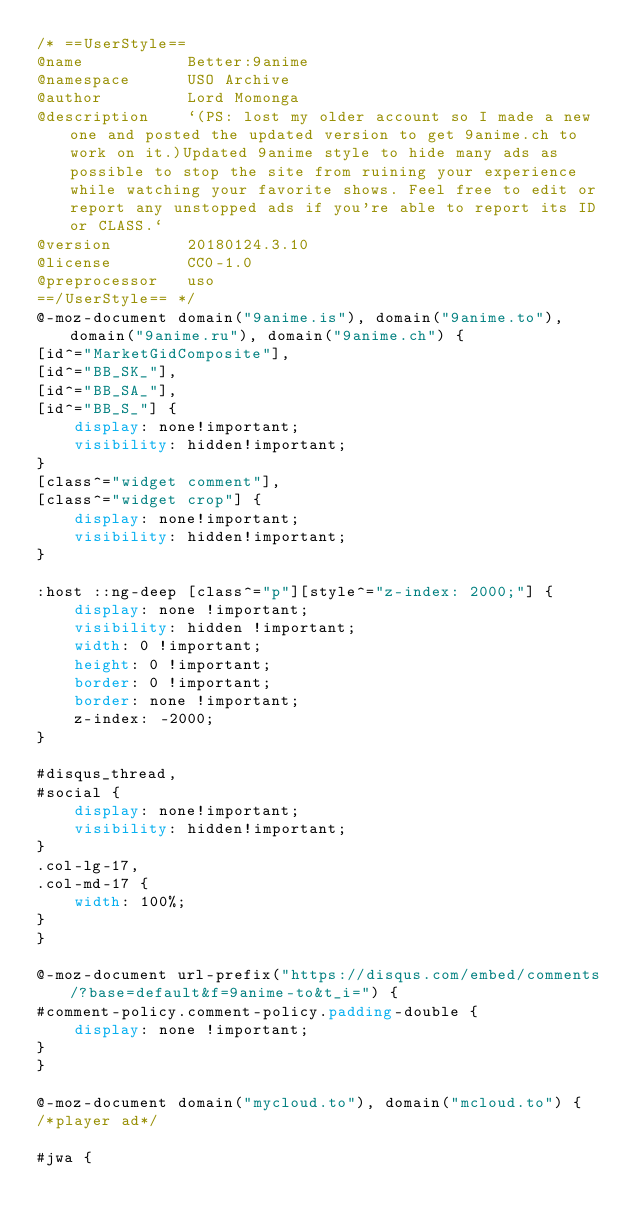Convert code to text. <code><loc_0><loc_0><loc_500><loc_500><_CSS_>/* ==UserStyle==
@name           Better:9anime
@namespace      USO Archive
@author         Lord Momonga
@description    `(PS: lost my older account so I made a new one and posted the updated version to get 9anime.ch to work on it.)Updated 9anime style to hide many ads as possible to stop the site from ruining your experience while watching your favorite shows. Feel free to edit or report any unstopped ads if you're able to report its ID or CLASS.`
@version        20180124.3.10
@license        CC0-1.0
@preprocessor   uso
==/UserStyle== */
@-moz-document domain("9anime.is"), domain("9anime.to"), domain("9anime.ru"), domain("9anime.ch") {
[id^="MarketGidComposite"],
[id^="BB_SK_"],
[id^="BB_SA_"],
[id^="BB_S_"] {
    display: none!important;
    visibility: hidden!important;
}
[class^="widget comment"],
[class^="widget crop"] {
    display: none!important;
    visibility: hidden!important;
}

:host ::ng-deep [class^="p"][style^="z-index: 2000;"] {
    display: none !important;
    visibility: hidden !important;
    width: 0 !important;
    height: 0 !important;
    border: 0 !important;
    border: none !important;
    z-index: -2000;
}

#disqus_thread,
#social {
    display: none!important;
    visibility: hidden!important;
}
.col-lg-17,
.col-md-17 {
    width: 100%;
}
}

@-moz-document url-prefix("https://disqus.com/embed/comments/?base=default&f=9anime-to&t_i=") {
#comment-policy.comment-policy.padding-double {
    display: none !important;
}
}

@-moz-document domain("mycloud.to"), domain("mcloud.to") {
/*player ad*/

#jwa {</code> 